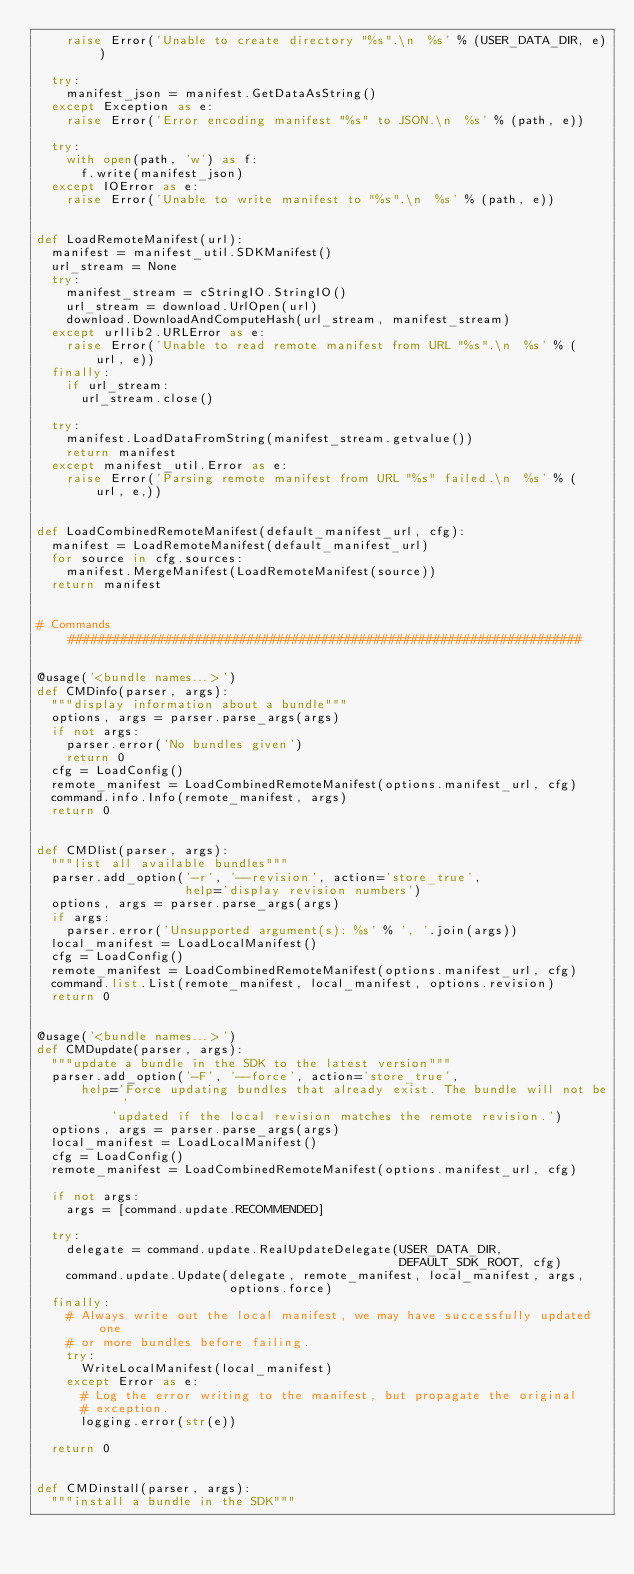Convert code to text. <code><loc_0><loc_0><loc_500><loc_500><_Python_>    raise Error('Unable to create directory "%s".\n  %s' % (USER_DATA_DIR, e))

  try:
    manifest_json = manifest.GetDataAsString()
  except Exception as e:
    raise Error('Error encoding manifest "%s" to JSON.\n  %s' % (path, e))

  try:
    with open(path, 'w') as f:
      f.write(manifest_json)
  except IOError as e:
    raise Error('Unable to write manifest to "%s".\n  %s' % (path, e))


def LoadRemoteManifest(url):
  manifest = manifest_util.SDKManifest()
  url_stream = None
  try:
    manifest_stream = cStringIO.StringIO()
    url_stream = download.UrlOpen(url)
    download.DownloadAndComputeHash(url_stream, manifest_stream)
  except urllib2.URLError as e:
    raise Error('Unable to read remote manifest from URL "%s".\n  %s' % (
        url, e))
  finally:
    if url_stream:
      url_stream.close()

  try:
    manifest.LoadDataFromString(manifest_stream.getvalue())
    return manifest
  except manifest_util.Error as e:
    raise Error('Parsing remote manifest from URL "%s" failed.\n  %s' % (
        url, e,))


def LoadCombinedRemoteManifest(default_manifest_url, cfg):
  manifest = LoadRemoteManifest(default_manifest_url)
  for source in cfg.sources:
    manifest.MergeManifest(LoadRemoteManifest(source))
  return manifest


# Commands #####################################################################


@usage('<bundle names...>')
def CMDinfo(parser, args):
  """display information about a bundle"""
  options, args = parser.parse_args(args)
  if not args:
    parser.error('No bundles given')
    return 0
  cfg = LoadConfig()
  remote_manifest = LoadCombinedRemoteManifest(options.manifest_url, cfg)
  command.info.Info(remote_manifest, args)
  return 0


def CMDlist(parser, args):
  """list all available bundles"""
  parser.add_option('-r', '--revision', action='store_true',
                    help='display revision numbers')
  options, args = parser.parse_args(args)
  if args:
    parser.error('Unsupported argument(s): %s' % ', '.join(args))
  local_manifest = LoadLocalManifest()
  cfg = LoadConfig()
  remote_manifest = LoadCombinedRemoteManifest(options.manifest_url, cfg)
  command.list.List(remote_manifest, local_manifest, options.revision)
  return 0


@usage('<bundle names...>')
def CMDupdate(parser, args):
  """update a bundle in the SDK to the latest version"""
  parser.add_option('-F', '--force', action='store_true',
      help='Force updating bundles that already exist. The bundle will not be '
          'updated if the local revision matches the remote revision.')
  options, args = parser.parse_args(args)
  local_manifest = LoadLocalManifest()
  cfg = LoadConfig()
  remote_manifest = LoadCombinedRemoteManifest(options.manifest_url, cfg)

  if not args:
    args = [command.update.RECOMMENDED]

  try:
    delegate = command.update.RealUpdateDelegate(USER_DATA_DIR,
                                                 DEFAULT_SDK_ROOT, cfg)
    command.update.Update(delegate, remote_manifest, local_manifest, args,
                          options.force)
  finally:
    # Always write out the local manifest, we may have successfully updated one
    # or more bundles before failing.
    try:
      WriteLocalManifest(local_manifest)
    except Error as e:
      # Log the error writing to the manifest, but propagate the original
      # exception.
      logging.error(str(e))

  return 0


def CMDinstall(parser, args):
  """install a bundle in the SDK"""</code> 